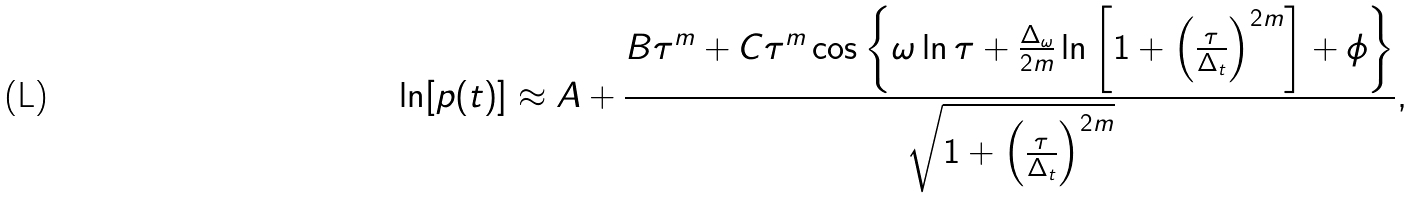<formula> <loc_0><loc_0><loc_500><loc_500>\ln [ p ( t ) ] \approx A + \frac { B \tau ^ { m } + C \tau ^ { m } \cos \left \{ \omega \ln \tau + \frac { \Delta _ { \omega } } { 2 m } \ln \left [ 1 + \left ( \frac { \tau } { \Delta _ { t } } \right ) ^ { 2 m } \right ] + \phi \right \} } { \sqrt { 1 + \left ( \frac { \tau } { \Delta _ { t } } \right ) ^ { 2 m } } } ,</formula> 